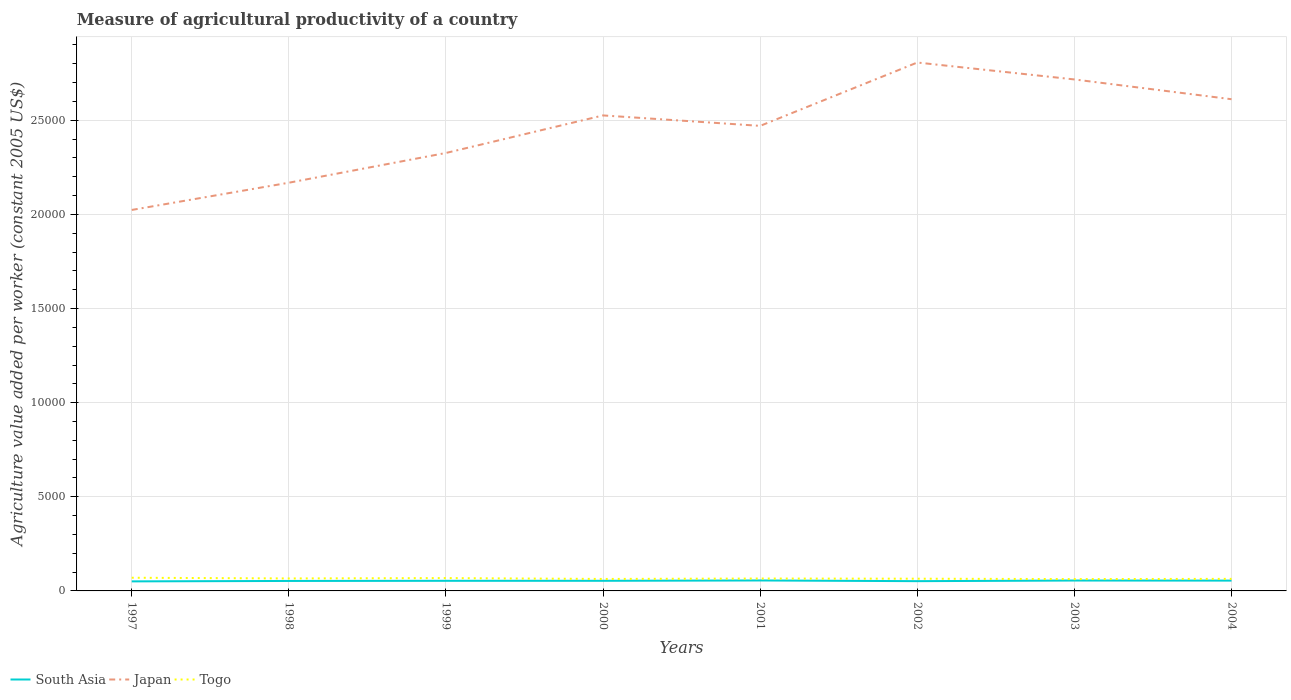Is the number of lines equal to the number of legend labels?
Provide a succinct answer. Yes. Across all years, what is the maximum measure of agricultural productivity in Japan?
Your response must be concise. 2.02e+04. What is the total measure of agricultural productivity in South Asia in the graph?
Give a very brief answer. -11.91. What is the difference between the highest and the second highest measure of agricultural productivity in Japan?
Your response must be concise. 7830.93. What is the difference between the highest and the lowest measure of agricultural productivity in Togo?
Keep it short and to the point. 4. How many lines are there?
Provide a succinct answer. 3. How many years are there in the graph?
Keep it short and to the point. 8. Does the graph contain any zero values?
Provide a short and direct response. No. Does the graph contain grids?
Your response must be concise. Yes. Where does the legend appear in the graph?
Provide a succinct answer. Bottom left. How many legend labels are there?
Your answer should be compact. 3. How are the legend labels stacked?
Ensure brevity in your answer.  Horizontal. What is the title of the graph?
Offer a terse response. Measure of agricultural productivity of a country. Does "Fragile and conflict affected situations" appear as one of the legend labels in the graph?
Your answer should be very brief. No. What is the label or title of the Y-axis?
Offer a terse response. Agriculture value added per worker (constant 2005 US$). What is the Agriculture value added per worker (constant 2005 US$) of South Asia in 1997?
Ensure brevity in your answer.  506.93. What is the Agriculture value added per worker (constant 2005 US$) of Japan in 1997?
Offer a very short reply. 2.02e+04. What is the Agriculture value added per worker (constant 2005 US$) of Togo in 1997?
Your response must be concise. 700.08. What is the Agriculture value added per worker (constant 2005 US$) in South Asia in 1998?
Keep it short and to the point. 529.46. What is the Agriculture value added per worker (constant 2005 US$) of Japan in 1998?
Your response must be concise. 2.17e+04. What is the Agriculture value added per worker (constant 2005 US$) in Togo in 1998?
Ensure brevity in your answer.  663.32. What is the Agriculture value added per worker (constant 2005 US$) in South Asia in 1999?
Provide a succinct answer. 537.23. What is the Agriculture value added per worker (constant 2005 US$) in Japan in 1999?
Make the answer very short. 2.33e+04. What is the Agriculture value added per worker (constant 2005 US$) of Togo in 1999?
Ensure brevity in your answer.  682.25. What is the Agriculture value added per worker (constant 2005 US$) in South Asia in 2000?
Give a very brief answer. 537.68. What is the Agriculture value added per worker (constant 2005 US$) in Japan in 2000?
Provide a succinct answer. 2.53e+04. What is the Agriculture value added per worker (constant 2005 US$) in Togo in 2000?
Your answer should be compact. 635.84. What is the Agriculture value added per worker (constant 2005 US$) of South Asia in 2001?
Your answer should be compact. 555.33. What is the Agriculture value added per worker (constant 2005 US$) in Japan in 2001?
Provide a succinct answer. 2.47e+04. What is the Agriculture value added per worker (constant 2005 US$) of Togo in 2001?
Provide a succinct answer. 658.87. What is the Agriculture value added per worker (constant 2005 US$) in South Asia in 2002?
Provide a succinct answer. 518.84. What is the Agriculture value added per worker (constant 2005 US$) of Japan in 2002?
Make the answer very short. 2.81e+04. What is the Agriculture value added per worker (constant 2005 US$) of Togo in 2002?
Keep it short and to the point. 649.45. What is the Agriculture value added per worker (constant 2005 US$) in South Asia in 2003?
Make the answer very short. 551.86. What is the Agriculture value added per worker (constant 2005 US$) of Japan in 2003?
Offer a terse response. 2.72e+04. What is the Agriculture value added per worker (constant 2005 US$) in Togo in 2003?
Your response must be concise. 628.99. What is the Agriculture value added per worker (constant 2005 US$) of South Asia in 2004?
Your answer should be very brief. 547.74. What is the Agriculture value added per worker (constant 2005 US$) in Japan in 2004?
Provide a succinct answer. 2.61e+04. What is the Agriculture value added per worker (constant 2005 US$) of Togo in 2004?
Provide a succinct answer. 640.82. Across all years, what is the maximum Agriculture value added per worker (constant 2005 US$) in South Asia?
Your response must be concise. 555.33. Across all years, what is the maximum Agriculture value added per worker (constant 2005 US$) in Japan?
Provide a short and direct response. 2.81e+04. Across all years, what is the maximum Agriculture value added per worker (constant 2005 US$) of Togo?
Make the answer very short. 700.08. Across all years, what is the minimum Agriculture value added per worker (constant 2005 US$) in South Asia?
Provide a short and direct response. 506.93. Across all years, what is the minimum Agriculture value added per worker (constant 2005 US$) in Japan?
Offer a terse response. 2.02e+04. Across all years, what is the minimum Agriculture value added per worker (constant 2005 US$) of Togo?
Make the answer very short. 628.99. What is the total Agriculture value added per worker (constant 2005 US$) in South Asia in the graph?
Give a very brief answer. 4285.06. What is the total Agriculture value added per worker (constant 2005 US$) of Japan in the graph?
Your answer should be compact. 1.96e+05. What is the total Agriculture value added per worker (constant 2005 US$) of Togo in the graph?
Give a very brief answer. 5259.62. What is the difference between the Agriculture value added per worker (constant 2005 US$) in South Asia in 1997 and that in 1998?
Make the answer very short. -22.53. What is the difference between the Agriculture value added per worker (constant 2005 US$) of Japan in 1997 and that in 1998?
Provide a succinct answer. -1446.39. What is the difference between the Agriculture value added per worker (constant 2005 US$) in Togo in 1997 and that in 1998?
Provide a succinct answer. 36.75. What is the difference between the Agriculture value added per worker (constant 2005 US$) in South Asia in 1997 and that in 1999?
Offer a terse response. -30.3. What is the difference between the Agriculture value added per worker (constant 2005 US$) of Japan in 1997 and that in 1999?
Keep it short and to the point. -3026.53. What is the difference between the Agriculture value added per worker (constant 2005 US$) of Togo in 1997 and that in 1999?
Give a very brief answer. 17.83. What is the difference between the Agriculture value added per worker (constant 2005 US$) of South Asia in 1997 and that in 2000?
Make the answer very short. -30.76. What is the difference between the Agriculture value added per worker (constant 2005 US$) of Japan in 1997 and that in 2000?
Offer a terse response. -5021.11. What is the difference between the Agriculture value added per worker (constant 2005 US$) of Togo in 1997 and that in 2000?
Offer a terse response. 64.24. What is the difference between the Agriculture value added per worker (constant 2005 US$) of South Asia in 1997 and that in 2001?
Your answer should be compact. -48.41. What is the difference between the Agriculture value added per worker (constant 2005 US$) in Japan in 1997 and that in 2001?
Your answer should be very brief. -4465.92. What is the difference between the Agriculture value added per worker (constant 2005 US$) of Togo in 1997 and that in 2001?
Provide a short and direct response. 41.2. What is the difference between the Agriculture value added per worker (constant 2005 US$) in South Asia in 1997 and that in 2002?
Offer a terse response. -11.91. What is the difference between the Agriculture value added per worker (constant 2005 US$) of Japan in 1997 and that in 2002?
Ensure brevity in your answer.  -7830.93. What is the difference between the Agriculture value added per worker (constant 2005 US$) of Togo in 1997 and that in 2002?
Provide a short and direct response. 50.63. What is the difference between the Agriculture value added per worker (constant 2005 US$) in South Asia in 1997 and that in 2003?
Your answer should be compact. -44.93. What is the difference between the Agriculture value added per worker (constant 2005 US$) of Japan in 1997 and that in 2003?
Offer a terse response. -6932. What is the difference between the Agriculture value added per worker (constant 2005 US$) of Togo in 1997 and that in 2003?
Your answer should be very brief. 71.09. What is the difference between the Agriculture value added per worker (constant 2005 US$) of South Asia in 1997 and that in 2004?
Provide a short and direct response. -40.81. What is the difference between the Agriculture value added per worker (constant 2005 US$) in Japan in 1997 and that in 2004?
Your answer should be compact. -5880.94. What is the difference between the Agriculture value added per worker (constant 2005 US$) of Togo in 1997 and that in 2004?
Offer a terse response. 59.26. What is the difference between the Agriculture value added per worker (constant 2005 US$) in South Asia in 1998 and that in 1999?
Your answer should be very brief. -7.77. What is the difference between the Agriculture value added per worker (constant 2005 US$) of Japan in 1998 and that in 1999?
Make the answer very short. -1580.14. What is the difference between the Agriculture value added per worker (constant 2005 US$) in Togo in 1998 and that in 1999?
Offer a very short reply. -18.92. What is the difference between the Agriculture value added per worker (constant 2005 US$) of South Asia in 1998 and that in 2000?
Ensure brevity in your answer.  -8.23. What is the difference between the Agriculture value added per worker (constant 2005 US$) of Japan in 1998 and that in 2000?
Provide a short and direct response. -3574.72. What is the difference between the Agriculture value added per worker (constant 2005 US$) in Togo in 1998 and that in 2000?
Your response must be concise. 27.49. What is the difference between the Agriculture value added per worker (constant 2005 US$) of South Asia in 1998 and that in 2001?
Ensure brevity in your answer.  -25.88. What is the difference between the Agriculture value added per worker (constant 2005 US$) in Japan in 1998 and that in 2001?
Your response must be concise. -3019.53. What is the difference between the Agriculture value added per worker (constant 2005 US$) of Togo in 1998 and that in 2001?
Keep it short and to the point. 4.45. What is the difference between the Agriculture value added per worker (constant 2005 US$) of South Asia in 1998 and that in 2002?
Your answer should be very brief. 10.62. What is the difference between the Agriculture value added per worker (constant 2005 US$) of Japan in 1998 and that in 2002?
Ensure brevity in your answer.  -6384.54. What is the difference between the Agriculture value added per worker (constant 2005 US$) of Togo in 1998 and that in 2002?
Make the answer very short. 13.88. What is the difference between the Agriculture value added per worker (constant 2005 US$) of South Asia in 1998 and that in 2003?
Your response must be concise. -22.4. What is the difference between the Agriculture value added per worker (constant 2005 US$) in Japan in 1998 and that in 2003?
Your answer should be very brief. -5485.61. What is the difference between the Agriculture value added per worker (constant 2005 US$) of Togo in 1998 and that in 2003?
Keep it short and to the point. 34.34. What is the difference between the Agriculture value added per worker (constant 2005 US$) of South Asia in 1998 and that in 2004?
Provide a succinct answer. -18.28. What is the difference between the Agriculture value added per worker (constant 2005 US$) in Japan in 1998 and that in 2004?
Your answer should be very brief. -4434.56. What is the difference between the Agriculture value added per worker (constant 2005 US$) of Togo in 1998 and that in 2004?
Ensure brevity in your answer.  22.5. What is the difference between the Agriculture value added per worker (constant 2005 US$) in South Asia in 1999 and that in 2000?
Provide a short and direct response. -0.46. What is the difference between the Agriculture value added per worker (constant 2005 US$) in Japan in 1999 and that in 2000?
Your answer should be compact. -1994.58. What is the difference between the Agriculture value added per worker (constant 2005 US$) in Togo in 1999 and that in 2000?
Ensure brevity in your answer.  46.41. What is the difference between the Agriculture value added per worker (constant 2005 US$) in South Asia in 1999 and that in 2001?
Offer a terse response. -18.11. What is the difference between the Agriculture value added per worker (constant 2005 US$) of Japan in 1999 and that in 2001?
Offer a very short reply. -1439.39. What is the difference between the Agriculture value added per worker (constant 2005 US$) in Togo in 1999 and that in 2001?
Provide a short and direct response. 23.37. What is the difference between the Agriculture value added per worker (constant 2005 US$) of South Asia in 1999 and that in 2002?
Make the answer very short. 18.39. What is the difference between the Agriculture value added per worker (constant 2005 US$) of Japan in 1999 and that in 2002?
Your answer should be compact. -4804.4. What is the difference between the Agriculture value added per worker (constant 2005 US$) of Togo in 1999 and that in 2002?
Make the answer very short. 32.8. What is the difference between the Agriculture value added per worker (constant 2005 US$) in South Asia in 1999 and that in 2003?
Make the answer very short. -14.63. What is the difference between the Agriculture value added per worker (constant 2005 US$) of Japan in 1999 and that in 2003?
Make the answer very short. -3905.46. What is the difference between the Agriculture value added per worker (constant 2005 US$) of Togo in 1999 and that in 2003?
Give a very brief answer. 53.26. What is the difference between the Agriculture value added per worker (constant 2005 US$) in South Asia in 1999 and that in 2004?
Your response must be concise. -10.51. What is the difference between the Agriculture value added per worker (constant 2005 US$) in Japan in 1999 and that in 2004?
Make the answer very short. -2854.41. What is the difference between the Agriculture value added per worker (constant 2005 US$) of Togo in 1999 and that in 2004?
Offer a terse response. 41.43. What is the difference between the Agriculture value added per worker (constant 2005 US$) of South Asia in 2000 and that in 2001?
Make the answer very short. -17.65. What is the difference between the Agriculture value added per worker (constant 2005 US$) of Japan in 2000 and that in 2001?
Give a very brief answer. 555.19. What is the difference between the Agriculture value added per worker (constant 2005 US$) of Togo in 2000 and that in 2001?
Offer a very short reply. -23.04. What is the difference between the Agriculture value added per worker (constant 2005 US$) of South Asia in 2000 and that in 2002?
Your answer should be compact. 18.85. What is the difference between the Agriculture value added per worker (constant 2005 US$) in Japan in 2000 and that in 2002?
Give a very brief answer. -2809.82. What is the difference between the Agriculture value added per worker (constant 2005 US$) of Togo in 2000 and that in 2002?
Make the answer very short. -13.61. What is the difference between the Agriculture value added per worker (constant 2005 US$) of South Asia in 2000 and that in 2003?
Make the answer very short. -14.18. What is the difference between the Agriculture value added per worker (constant 2005 US$) in Japan in 2000 and that in 2003?
Keep it short and to the point. -1910.89. What is the difference between the Agriculture value added per worker (constant 2005 US$) in Togo in 2000 and that in 2003?
Make the answer very short. 6.85. What is the difference between the Agriculture value added per worker (constant 2005 US$) of South Asia in 2000 and that in 2004?
Your answer should be very brief. -10.05. What is the difference between the Agriculture value added per worker (constant 2005 US$) of Japan in 2000 and that in 2004?
Keep it short and to the point. -859.84. What is the difference between the Agriculture value added per worker (constant 2005 US$) in Togo in 2000 and that in 2004?
Give a very brief answer. -4.98. What is the difference between the Agriculture value added per worker (constant 2005 US$) in South Asia in 2001 and that in 2002?
Keep it short and to the point. 36.5. What is the difference between the Agriculture value added per worker (constant 2005 US$) in Japan in 2001 and that in 2002?
Provide a short and direct response. -3365.01. What is the difference between the Agriculture value added per worker (constant 2005 US$) of Togo in 2001 and that in 2002?
Your answer should be very brief. 9.43. What is the difference between the Agriculture value added per worker (constant 2005 US$) of South Asia in 2001 and that in 2003?
Provide a short and direct response. 3.47. What is the difference between the Agriculture value added per worker (constant 2005 US$) of Japan in 2001 and that in 2003?
Offer a very short reply. -2466.08. What is the difference between the Agriculture value added per worker (constant 2005 US$) in Togo in 2001 and that in 2003?
Give a very brief answer. 29.88. What is the difference between the Agriculture value added per worker (constant 2005 US$) of South Asia in 2001 and that in 2004?
Your response must be concise. 7.6. What is the difference between the Agriculture value added per worker (constant 2005 US$) of Japan in 2001 and that in 2004?
Provide a succinct answer. -1415.02. What is the difference between the Agriculture value added per worker (constant 2005 US$) of Togo in 2001 and that in 2004?
Offer a very short reply. 18.05. What is the difference between the Agriculture value added per worker (constant 2005 US$) in South Asia in 2002 and that in 2003?
Your answer should be compact. -33.02. What is the difference between the Agriculture value added per worker (constant 2005 US$) of Japan in 2002 and that in 2003?
Your response must be concise. 898.93. What is the difference between the Agriculture value added per worker (constant 2005 US$) in Togo in 2002 and that in 2003?
Offer a very short reply. 20.46. What is the difference between the Agriculture value added per worker (constant 2005 US$) in South Asia in 2002 and that in 2004?
Provide a short and direct response. -28.9. What is the difference between the Agriculture value added per worker (constant 2005 US$) in Japan in 2002 and that in 2004?
Offer a very short reply. 1949.99. What is the difference between the Agriculture value added per worker (constant 2005 US$) of Togo in 2002 and that in 2004?
Your response must be concise. 8.63. What is the difference between the Agriculture value added per worker (constant 2005 US$) of South Asia in 2003 and that in 2004?
Your answer should be compact. 4.12. What is the difference between the Agriculture value added per worker (constant 2005 US$) of Japan in 2003 and that in 2004?
Give a very brief answer. 1051.05. What is the difference between the Agriculture value added per worker (constant 2005 US$) of Togo in 2003 and that in 2004?
Your answer should be compact. -11.83. What is the difference between the Agriculture value added per worker (constant 2005 US$) of South Asia in 1997 and the Agriculture value added per worker (constant 2005 US$) of Japan in 1998?
Your answer should be compact. -2.12e+04. What is the difference between the Agriculture value added per worker (constant 2005 US$) of South Asia in 1997 and the Agriculture value added per worker (constant 2005 US$) of Togo in 1998?
Ensure brevity in your answer.  -156.4. What is the difference between the Agriculture value added per worker (constant 2005 US$) of Japan in 1997 and the Agriculture value added per worker (constant 2005 US$) of Togo in 1998?
Provide a short and direct response. 1.96e+04. What is the difference between the Agriculture value added per worker (constant 2005 US$) in South Asia in 1997 and the Agriculture value added per worker (constant 2005 US$) in Japan in 1999?
Your response must be concise. -2.28e+04. What is the difference between the Agriculture value added per worker (constant 2005 US$) in South Asia in 1997 and the Agriculture value added per worker (constant 2005 US$) in Togo in 1999?
Your response must be concise. -175.32. What is the difference between the Agriculture value added per worker (constant 2005 US$) in Japan in 1997 and the Agriculture value added per worker (constant 2005 US$) in Togo in 1999?
Make the answer very short. 1.96e+04. What is the difference between the Agriculture value added per worker (constant 2005 US$) in South Asia in 1997 and the Agriculture value added per worker (constant 2005 US$) in Japan in 2000?
Your answer should be compact. -2.48e+04. What is the difference between the Agriculture value added per worker (constant 2005 US$) in South Asia in 1997 and the Agriculture value added per worker (constant 2005 US$) in Togo in 2000?
Offer a terse response. -128.91. What is the difference between the Agriculture value added per worker (constant 2005 US$) of Japan in 1997 and the Agriculture value added per worker (constant 2005 US$) of Togo in 2000?
Make the answer very short. 1.96e+04. What is the difference between the Agriculture value added per worker (constant 2005 US$) of South Asia in 1997 and the Agriculture value added per worker (constant 2005 US$) of Japan in 2001?
Provide a short and direct response. -2.42e+04. What is the difference between the Agriculture value added per worker (constant 2005 US$) of South Asia in 1997 and the Agriculture value added per worker (constant 2005 US$) of Togo in 2001?
Give a very brief answer. -151.95. What is the difference between the Agriculture value added per worker (constant 2005 US$) in Japan in 1997 and the Agriculture value added per worker (constant 2005 US$) in Togo in 2001?
Your response must be concise. 1.96e+04. What is the difference between the Agriculture value added per worker (constant 2005 US$) of South Asia in 1997 and the Agriculture value added per worker (constant 2005 US$) of Japan in 2002?
Your response must be concise. -2.76e+04. What is the difference between the Agriculture value added per worker (constant 2005 US$) of South Asia in 1997 and the Agriculture value added per worker (constant 2005 US$) of Togo in 2002?
Your answer should be compact. -142.52. What is the difference between the Agriculture value added per worker (constant 2005 US$) in Japan in 1997 and the Agriculture value added per worker (constant 2005 US$) in Togo in 2002?
Offer a terse response. 1.96e+04. What is the difference between the Agriculture value added per worker (constant 2005 US$) in South Asia in 1997 and the Agriculture value added per worker (constant 2005 US$) in Japan in 2003?
Give a very brief answer. -2.67e+04. What is the difference between the Agriculture value added per worker (constant 2005 US$) in South Asia in 1997 and the Agriculture value added per worker (constant 2005 US$) in Togo in 2003?
Your answer should be very brief. -122.06. What is the difference between the Agriculture value added per worker (constant 2005 US$) in Japan in 1997 and the Agriculture value added per worker (constant 2005 US$) in Togo in 2003?
Make the answer very short. 1.96e+04. What is the difference between the Agriculture value added per worker (constant 2005 US$) in South Asia in 1997 and the Agriculture value added per worker (constant 2005 US$) in Japan in 2004?
Keep it short and to the point. -2.56e+04. What is the difference between the Agriculture value added per worker (constant 2005 US$) of South Asia in 1997 and the Agriculture value added per worker (constant 2005 US$) of Togo in 2004?
Give a very brief answer. -133.89. What is the difference between the Agriculture value added per worker (constant 2005 US$) of Japan in 1997 and the Agriculture value added per worker (constant 2005 US$) of Togo in 2004?
Offer a very short reply. 1.96e+04. What is the difference between the Agriculture value added per worker (constant 2005 US$) in South Asia in 1998 and the Agriculture value added per worker (constant 2005 US$) in Japan in 1999?
Keep it short and to the point. -2.27e+04. What is the difference between the Agriculture value added per worker (constant 2005 US$) of South Asia in 1998 and the Agriculture value added per worker (constant 2005 US$) of Togo in 1999?
Your answer should be compact. -152.79. What is the difference between the Agriculture value added per worker (constant 2005 US$) in Japan in 1998 and the Agriculture value added per worker (constant 2005 US$) in Togo in 1999?
Your answer should be compact. 2.10e+04. What is the difference between the Agriculture value added per worker (constant 2005 US$) of South Asia in 1998 and the Agriculture value added per worker (constant 2005 US$) of Japan in 2000?
Your response must be concise. -2.47e+04. What is the difference between the Agriculture value added per worker (constant 2005 US$) in South Asia in 1998 and the Agriculture value added per worker (constant 2005 US$) in Togo in 2000?
Your answer should be compact. -106.38. What is the difference between the Agriculture value added per worker (constant 2005 US$) of Japan in 1998 and the Agriculture value added per worker (constant 2005 US$) of Togo in 2000?
Give a very brief answer. 2.10e+04. What is the difference between the Agriculture value added per worker (constant 2005 US$) in South Asia in 1998 and the Agriculture value added per worker (constant 2005 US$) in Japan in 2001?
Your answer should be compact. -2.42e+04. What is the difference between the Agriculture value added per worker (constant 2005 US$) in South Asia in 1998 and the Agriculture value added per worker (constant 2005 US$) in Togo in 2001?
Offer a very short reply. -129.42. What is the difference between the Agriculture value added per worker (constant 2005 US$) in Japan in 1998 and the Agriculture value added per worker (constant 2005 US$) in Togo in 2001?
Offer a very short reply. 2.10e+04. What is the difference between the Agriculture value added per worker (constant 2005 US$) in South Asia in 1998 and the Agriculture value added per worker (constant 2005 US$) in Japan in 2002?
Your answer should be compact. -2.75e+04. What is the difference between the Agriculture value added per worker (constant 2005 US$) of South Asia in 1998 and the Agriculture value added per worker (constant 2005 US$) of Togo in 2002?
Provide a short and direct response. -119.99. What is the difference between the Agriculture value added per worker (constant 2005 US$) in Japan in 1998 and the Agriculture value added per worker (constant 2005 US$) in Togo in 2002?
Ensure brevity in your answer.  2.10e+04. What is the difference between the Agriculture value added per worker (constant 2005 US$) of South Asia in 1998 and the Agriculture value added per worker (constant 2005 US$) of Japan in 2003?
Your response must be concise. -2.66e+04. What is the difference between the Agriculture value added per worker (constant 2005 US$) in South Asia in 1998 and the Agriculture value added per worker (constant 2005 US$) in Togo in 2003?
Give a very brief answer. -99.53. What is the difference between the Agriculture value added per worker (constant 2005 US$) of Japan in 1998 and the Agriculture value added per worker (constant 2005 US$) of Togo in 2003?
Your answer should be compact. 2.11e+04. What is the difference between the Agriculture value added per worker (constant 2005 US$) of South Asia in 1998 and the Agriculture value added per worker (constant 2005 US$) of Japan in 2004?
Offer a very short reply. -2.56e+04. What is the difference between the Agriculture value added per worker (constant 2005 US$) in South Asia in 1998 and the Agriculture value added per worker (constant 2005 US$) in Togo in 2004?
Offer a terse response. -111.36. What is the difference between the Agriculture value added per worker (constant 2005 US$) of Japan in 1998 and the Agriculture value added per worker (constant 2005 US$) of Togo in 2004?
Your answer should be compact. 2.10e+04. What is the difference between the Agriculture value added per worker (constant 2005 US$) in South Asia in 1999 and the Agriculture value added per worker (constant 2005 US$) in Japan in 2000?
Provide a succinct answer. -2.47e+04. What is the difference between the Agriculture value added per worker (constant 2005 US$) in South Asia in 1999 and the Agriculture value added per worker (constant 2005 US$) in Togo in 2000?
Offer a terse response. -98.61. What is the difference between the Agriculture value added per worker (constant 2005 US$) in Japan in 1999 and the Agriculture value added per worker (constant 2005 US$) in Togo in 2000?
Offer a very short reply. 2.26e+04. What is the difference between the Agriculture value added per worker (constant 2005 US$) of South Asia in 1999 and the Agriculture value added per worker (constant 2005 US$) of Japan in 2001?
Keep it short and to the point. -2.42e+04. What is the difference between the Agriculture value added per worker (constant 2005 US$) in South Asia in 1999 and the Agriculture value added per worker (constant 2005 US$) in Togo in 2001?
Make the answer very short. -121.65. What is the difference between the Agriculture value added per worker (constant 2005 US$) of Japan in 1999 and the Agriculture value added per worker (constant 2005 US$) of Togo in 2001?
Provide a short and direct response. 2.26e+04. What is the difference between the Agriculture value added per worker (constant 2005 US$) in South Asia in 1999 and the Agriculture value added per worker (constant 2005 US$) in Japan in 2002?
Your answer should be compact. -2.75e+04. What is the difference between the Agriculture value added per worker (constant 2005 US$) in South Asia in 1999 and the Agriculture value added per worker (constant 2005 US$) in Togo in 2002?
Your answer should be compact. -112.22. What is the difference between the Agriculture value added per worker (constant 2005 US$) of Japan in 1999 and the Agriculture value added per worker (constant 2005 US$) of Togo in 2002?
Offer a terse response. 2.26e+04. What is the difference between the Agriculture value added per worker (constant 2005 US$) of South Asia in 1999 and the Agriculture value added per worker (constant 2005 US$) of Japan in 2003?
Offer a very short reply. -2.66e+04. What is the difference between the Agriculture value added per worker (constant 2005 US$) of South Asia in 1999 and the Agriculture value added per worker (constant 2005 US$) of Togo in 2003?
Ensure brevity in your answer.  -91.76. What is the difference between the Agriculture value added per worker (constant 2005 US$) in Japan in 1999 and the Agriculture value added per worker (constant 2005 US$) in Togo in 2003?
Provide a succinct answer. 2.26e+04. What is the difference between the Agriculture value added per worker (constant 2005 US$) in South Asia in 1999 and the Agriculture value added per worker (constant 2005 US$) in Japan in 2004?
Provide a short and direct response. -2.56e+04. What is the difference between the Agriculture value added per worker (constant 2005 US$) in South Asia in 1999 and the Agriculture value added per worker (constant 2005 US$) in Togo in 2004?
Your answer should be very brief. -103.59. What is the difference between the Agriculture value added per worker (constant 2005 US$) of Japan in 1999 and the Agriculture value added per worker (constant 2005 US$) of Togo in 2004?
Give a very brief answer. 2.26e+04. What is the difference between the Agriculture value added per worker (constant 2005 US$) in South Asia in 2000 and the Agriculture value added per worker (constant 2005 US$) in Japan in 2001?
Offer a very short reply. -2.42e+04. What is the difference between the Agriculture value added per worker (constant 2005 US$) of South Asia in 2000 and the Agriculture value added per worker (constant 2005 US$) of Togo in 2001?
Keep it short and to the point. -121.19. What is the difference between the Agriculture value added per worker (constant 2005 US$) of Japan in 2000 and the Agriculture value added per worker (constant 2005 US$) of Togo in 2001?
Ensure brevity in your answer.  2.46e+04. What is the difference between the Agriculture value added per worker (constant 2005 US$) in South Asia in 2000 and the Agriculture value added per worker (constant 2005 US$) in Japan in 2002?
Offer a terse response. -2.75e+04. What is the difference between the Agriculture value added per worker (constant 2005 US$) of South Asia in 2000 and the Agriculture value added per worker (constant 2005 US$) of Togo in 2002?
Offer a terse response. -111.76. What is the difference between the Agriculture value added per worker (constant 2005 US$) in Japan in 2000 and the Agriculture value added per worker (constant 2005 US$) in Togo in 2002?
Keep it short and to the point. 2.46e+04. What is the difference between the Agriculture value added per worker (constant 2005 US$) in South Asia in 2000 and the Agriculture value added per worker (constant 2005 US$) in Japan in 2003?
Ensure brevity in your answer.  -2.66e+04. What is the difference between the Agriculture value added per worker (constant 2005 US$) of South Asia in 2000 and the Agriculture value added per worker (constant 2005 US$) of Togo in 2003?
Your response must be concise. -91.31. What is the difference between the Agriculture value added per worker (constant 2005 US$) in Japan in 2000 and the Agriculture value added per worker (constant 2005 US$) in Togo in 2003?
Keep it short and to the point. 2.46e+04. What is the difference between the Agriculture value added per worker (constant 2005 US$) in South Asia in 2000 and the Agriculture value added per worker (constant 2005 US$) in Japan in 2004?
Offer a terse response. -2.56e+04. What is the difference between the Agriculture value added per worker (constant 2005 US$) of South Asia in 2000 and the Agriculture value added per worker (constant 2005 US$) of Togo in 2004?
Provide a succinct answer. -103.14. What is the difference between the Agriculture value added per worker (constant 2005 US$) of Japan in 2000 and the Agriculture value added per worker (constant 2005 US$) of Togo in 2004?
Keep it short and to the point. 2.46e+04. What is the difference between the Agriculture value added per worker (constant 2005 US$) in South Asia in 2001 and the Agriculture value added per worker (constant 2005 US$) in Japan in 2002?
Provide a short and direct response. -2.75e+04. What is the difference between the Agriculture value added per worker (constant 2005 US$) in South Asia in 2001 and the Agriculture value added per worker (constant 2005 US$) in Togo in 2002?
Provide a short and direct response. -94.11. What is the difference between the Agriculture value added per worker (constant 2005 US$) of Japan in 2001 and the Agriculture value added per worker (constant 2005 US$) of Togo in 2002?
Ensure brevity in your answer.  2.41e+04. What is the difference between the Agriculture value added per worker (constant 2005 US$) of South Asia in 2001 and the Agriculture value added per worker (constant 2005 US$) of Japan in 2003?
Offer a very short reply. -2.66e+04. What is the difference between the Agriculture value added per worker (constant 2005 US$) of South Asia in 2001 and the Agriculture value added per worker (constant 2005 US$) of Togo in 2003?
Offer a very short reply. -73.66. What is the difference between the Agriculture value added per worker (constant 2005 US$) in Japan in 2001 and the Agriculture value added per worker (constant 2005 US$) in Togo in 2003?
Your answer should be very brief. 2.41e+04. What is the difference between the Agriculture value added per worker (constant 2005 US$) in South Asia in 2001 and the Agriculture value added per worker (constant 2005 US$) in Japan in 2004?
Ensure brevity in your answer.  -2.56e+04. What is the difference between the Agriculture value added per worker (constant 2005 US$) in South Asia in 2001 and the Agriculture value added per worker (constant 2005 US$) in Togo in 2004?
Your answer should be very brief. -85.49. What is the difference between the Agriculture value added per worker (constant 2005 US$) in Japan in 2001 and the Agriculture value added per worker (constant 2005 US$) in Togo in 2004?
Your response must be concise. 2.41e+04. What is the difference between the Agriculture value added per worker (constant 2005 US$) of South Asia in 2002 and the Agriculture value added per worker (constant 2005 US$) of Japan in 2003?
Give a very brief answer. -2.66e+04. What is the difference between the Agriculture value added per worker (constant 2005 US$) in South Asia in 2002 and the Agriculture value added per worker (constant 2005 US$) in Togo in 2003?
Offer a very short reply. -110.15. What is the difference between the Agriculture value added per worker (constant 2005 US$) of Japan in 2002 and the Agriculture value added per worker (constant 2005 US$) of Togo in 2003?
Make the answer very short. 2.74e+04. What is the difference between the Agriculture value added per worker (constant 2005 US$) of South Asia in 2002 and the Agriculture value added per worker (constant 2005 US$) of Japan in 2004?
Ensure brevity in your answer.  -2.56e+04. What is the difference between the Agriculture value added per worker (constant 2005 US$) of South Asia in 2002 and the Agriculture value added per worker (constant 2005 US$) of Togo in 2004?
Offer a terse response. -121.98. What is the difference between the Agriculture value added per worker (constant 2005 US$) of Japan in 2002 and the Agriculture value added per worker (constant 2005 US$) of Togo in 2004?
Make the answer very short. 2.74e+04. What is the difference between the Agriculture value added per worker (constant 2005 US$) in South Asia in 2003 and the Agriculture value added per worker (constant 2005 US$) in Japan in 2004?
Your answer should be compact. -2.56e+04. What is the difference between the Agriculture value added per worker (constant 2005 US$) in South Asia in 2003 and the Agriculture value added per worker (constant 2005 US$) in Togo in 2004?
Give a very brief answer. -88.96. What is the difference between the Agriculture value added per worker (constant 2005 US$) of Japan in 2003 and the Agriculture value added per worker (constant 2005 US$) of Togo in 2004?
Ensure brevity in your answer.  2.65e+04. What is the average Agriculture value added per worker (constant 2005 US$) of South Asia per year?
Ensure brevity in your answer.  535.63. What is the average Agriculture value added per worker (constant 2005 US$) of Japan per year?
Your response must be concise. 2.46e+04. What is the average Agriculture value added per worker (constant 2005 US$) of Togo per year?
Give a very brief answer. 657.45. In the year 1997, what is the difference between the Agriculture value added per worker (constant 2005 US$) in South Asia and Agriculture value added per worker (constant 2005 US$) in Japan?
Offer a very short reply. -1.97e+04. In the year 1997, what is the difference between the Agriculture value added per worker (constant 2005 US$) of South Asia and Agriculture value added per worker (constant 2005 US$) of Togo?
Keep it short and to the point. -193.15. In the year 1997, what is the difference between the Agriculture value added per worker (constant 2005 US$) in Japan and Agriculture value added per worker (constant 2005 US$) in Togo?
Your answer should be very brief. 1.95e+04. In the year 1998, what is the difference between the Agriculture value added per worker (constant 2005 US$) of South Asia and Agriculture value added per worker (constant 2005 US$) of Japan?
Provide a succinct answer. -2.12e+04. In the year 1998, what is the difference between the Agriculture value added per worker (constant 2005 US$) of South Asia and Agriculture value added per worker (constant 2005 US$) of Togo?
Keep it short and to the point. -133.87. In the year 1998, what is the difference between the Agriculture value added per worker (constant 2005 US$) in Japan and Agriculture value added per worker (constant 2005 US$) in Togo?
Keep it short and to the point. 2.10e+04. In the year 1999, what is the difference between the Agriculture value added per worker (constant 2005 US$) of South Asia and Agriculture value added per worker (constant 2005 US$) of Japan?
Your answer should be compact. -2.27e+04. In the year 1999, what is the difference between the Agriculture value added per worker (constant 2005 US$) in South Asia and Agriculture value added per worker (constant 2005 US$) in Togo?
Provide a succinct answer. -145.02. In the year 1999, what is the difference between the Agriculture value added per worker (constant 2005 US$) in Japan and Agriculture value added per worker (constant 2005 US$) in Togo?
Give a very brief answer. 2.26e+04. In the year 2000, what is the difference between the Agriculture value added per worker (constant 2005 US$) in South Asia and Agriculture value added per worker (constant 2005 US$) in Japan?
Keep it short and to the point. -2.47e+04. In the year 2000, what is the difference between the Agriculture value added per worker (constant 2005 US$) in South Asia and Agriculture value added per worker (constant 2005 US$) in Togo?
Give a very brief answer. -98.15. In the year 2000, what is the difference between the Agriculture value added per worker (constant 2005 US$) of Japan and Agriculture value added per worker (constant 2005 US$) of Togo?
Ensure brevity in your answer.  2.46e+04. In the year 2001, what is the difference between the Agriculture value added per worker (constant 2005 US$) in South Asia and Agriculture value added per worker (constant 2005 US$) in Japan?
Offer a very short reply. -2.41e+04. In the year 2001, what is the difference between the Agriculture value added per worker (constant 2005 US$) of South Asia and Agriculture value added per worker (constant 2005 US$) of Togo?
Offer a terse response. -103.54. In the year 2001, what is the difference between the Agriculture value added per worker (constant 2005 US$) of Japan and Agriculture value added per worker (constant 2005 US$) of Togo?
Your answer should be very brief. 2.40e+04. In the year 2002, what is the difference between the Agriculture value added per worker (constant 2005 US$) in South Asia and Agriculture value added per worker (constant 2005 US$) in Japan?
Offer a terse response. -2.75e+04. In the year 2002, what is the difference between the Agriculture value added per worker (constant 2005 US$) of South Asia and Agriculture value added per worker (constant 2005 US$) of Togo?
Make the answer very short. -130.61. In the year 2002, what is the difference between the Agriculture value added per worker (constant 2005 US$) of Japan and Agriculture value added per worker (constant 2005 US$) of Togo?
Offer a terse response. 2.74e+04. In the year 2003, what is the difference between the Agriculture value added per worker (constant 2005 US$) of South Asia and Agriculture value added per worker (constant 2005 US$) of Japan?
Your response must be concise. -2.66e+04. In the year 2003, what is the difference between the Agriculture value added per worker (constant 2005 US$) of South Asia and Agriculture value added per worker (constant 2005 US$) of Togo?
Offer a very short reply. -77.13. In the year 2003, what is the difference between the Agriculture value added per worker (constant 2005 US$) in Japan and Agriculture value added per worker (constant 2005 US$) in Togo?
Give a very brief answer. 2.65e+04. In the year 2004, what is the difference between the Agriculture value added per worker (constant 2005 US$) in South Asia and Agriculture value added per worker (constant 2005 US$) in Japan?
Provide a succinct answer. -2.56e+04. In the year 2004, what is the difference between the Agriculture value added per worker (constant 2005 US$) of South Asia and Agriculture value added per worker (constant 2005 US$) of Togo?
Ensure brevity in your answer.  -93.08. In the year 2004, what is the difference between the Agriculture value added per worker (constant 2005 US$) of Japan and Agriculture value added per worker (constant 2005 US$) of Togo?
Offer a very short reply. 2.55e+04. What is the ratio of the Agriculture value added per worker (constant 2005 US$) of South Asia in 1997 to that in 1998?
Make the answer very short. 0.96. What is the ratio of the Agriculture value added per worker (constant 2005 US$) in Togo in 1997 to that in 1998?
Offer a very short reply. 1.06. What is the ratio of the Agriculture value added per worker (constant 2005 US$) of South Asia in 1997 to that in 1999?
Offer a terse response. 0.94. What is the ratio of the Agriculture value added per worker (constant 2005 US$) in Japan in 1997 to that in 1999?
Your answer should be very brief. 0.87. What is the ratio of the Agriculture value added per worker (constant 2005 US$) in Togo in 1997 to that in 1999?
Provide a short and direct response. 1.03. What is the ratio of the Agriculture value added per worker (constant 2005 US$) in South Asia in 1997 to that in 2000?
Ensure brevity in your answer.  0.94. What is the ratio of the Agriculture value added per worker (constant 2005 US$) of Japan in 1997 to that in 2000?
Give a very brief answer. 0.8. What is the ratio of the Agriculture value added per worker (constant 2005 US$) of Togo in 1997 to that in 2000?
Your answer should be very brief. 1.1. What is the ratio of the Agriculture value added per worker (constant 2005 US$) of South Asia in 1997 to that in 2001?
Your answer should be very brief. 0.91. What is the ratio of the Agriculture value added per worker (constant 2005 US$) in Japan in 1997 to that in 2001?
Provide a short and direct response. 0.82. What is the ratio of the Agriculture value added per worker (constant 2005 US$) in Togo in 1997 to that in 2001?
Your answer should be very brief. 1.06. What is the ratio of the Agriculture value added per worker (constant 2005 US$) of Japan in 1997 to that in 2002?
Offer a terse response. 0.72. What is the ratio of the Agriculture value added per worker (constant 2005 US$) of Togo in 1997 to that in 2002?
Your answer should be compact. 1.08. What is the ratio of the Agriculture value added per worker (constant 2005 US$) of South Asia in 1997 to that in 2003?
Your answer should be compact. 0.92. What is the ratio of the Agriculture value added per worker (constant 2005 US$) of Japan in 1997 to that in 2003?
Your response must be concise. 0.74. What is the ratio of the Agriculture value added per worker (constant 2005 US$) in Togo in 1997 to that in 2003?
Offer a very short reply. 1.11. What is the ratio of the Agriculture value added per worker (constant 2005 US$) in South Asia in 1997 to that in 2004?
Give a very brief answer. 0.93. What is the ratio of the Agriculture value added per worker (constant 2005 US$) in Japan in 1997 to that in 2004?
Your response must be concise. 0.77. What is the ratio of the Agriculture value added per worker (constant 2005 US$) in Togo in 1997 to that in 2004?
Provide a succinct answer. 1.09. What is the ratio of the Agriculture value added per worker (constant 2005 US$) of South Asia in 1998 to that in 1999?
Provide a short and direct response. 0.99. What is the ratio of the Agriculture value added per worker (constant 2005 US$) in Japan in 1998 to that in 1999?
Your answer should be compact. 0.93. What is the ratio of the Agriculture value added per worker (constant 2005 US$) in Togo in 1998 to that in 1999?
Your response must be concise. 0.97. What is the ratio of the Agriculture value added per worker (constant 2005 US$) in South Asia in 1998 to that in 2000?
Your answer should be very brief. 0.98. What is the ratio of the Agriculture value added per worker (constant 2005 US$) in Japan in 1998 to that in 2000?
Offer a very short reply. 0.86. What is the ratio of the Agriculture value added per worker (constant 2005 US$) in Togo in 1998 to that in 2000?
Your response must be concise. 1.04. What is the ratio of the Agriculture value added per worker (constant 2005 US$) in South Asia in 1998 to that in 2001?
Your response must be concise. 0.95. What is the ratio of the Agriculture value added per worker (constant 2005 US$) of Japan in 1998 to that in 2001?
Offer a terse response. 0.88. What is the ratio of the Agriculture value added per worker (constant 2005 US$) in Togo in 1998 to that in 2001?
Make the answer very short. 1.01. What is the ratio of the Agriculture value added per worker (constant 2005 US$) in South Asia in 1998 to that in 2002?
Keep it short and to the point. 1.02. What is the ratio of the Agriculture value added per worker (constant 2005 US$) of Japan in 1998 to that in 2002?
Offer a terse response. 0.77. What is the ratio of the Agriculture value added per worker (constant 2005 US$) in Togo in 1998 to that in 2002?
Make the answer very short. 1.02. What is the ratio of the Agriculture value added per worker (constant 2005 US$) of South Asia in 1998 to that in 2003?
Provide a short and direct response. 0.96. What is the ratio of the Agriculture value added per worker (constant 2005 US$) in Japan in 1998 to that in 2003?
Offer a terse response. 0.8. What is the ratio of the Agriculture value added per worker (constant 2005 US$) in Togo in 1998 to that in 2003?
Offer a terse response. 1.05. What is the ratio of the Agriculture value added per worker (constant 2005 US$) of South Asia in 1998 to that in 2004?
Your answer should be very brief. 0.97. What is the ratio of the Agriculture value added per worker (constant 2005 US$) of Japan in 1998 to that in 2004?
Your answer should be compact. 0.83. What is the ratio of the Agriculture value added per worker (constant 2005 US$) in Togo in 1998 to that in 2004?
Provide a succinct answer. 1.04. What is the ratio of the Agriculture value added per worker (constant 2005 US$) in South Asia in 1999 to that in 2000?
Provide a short and direct response. 1. What is the ratio of the Agriculture value added per worker (constant 2005 US$) in Japan in 1999 to that in 2000?
Offer a terse response. 0.92. What is the ratio of the Agriculture value added per worker (constant 2005 US$) of Togo in 1999 to that in 2000?
Your answer should be compact. 1.07. What is the ratio of the Agriculture value added per worker (constant 2005 US$) of South Asia in 1999 to that in 2001?
Your response must be concise. 0.97. What is the ratio of the Agriculture value added per worker (constant 2005 US$) of Japan in 1999 to that in 2001?
Your answer should be very brief. 0.94. What is the ratio of the Agriculture value added per worker (constant 2005 US$) in Togo in 1999 to that in 2001?
Offer a terse response. 1.04. What is the ratio of the Agriculture value added per worker (constant 2005 US$) in South Asia in 1999 to that in 2002?
Offer a very short reply. 1.04. What is the ratio of the Agriculture value added per worker (constant 2005 US$) in Japan in 1999 to that in 2002?
Give a very brief answer. 0.83. What is the ratio of the Agriculture value added per worker (constant 2005 US$) in Togo in 1999 to that in 2002?
Offer a terse response. 1.05. What is the ratio of the Agriculture value added per worker (constant 2005 US$) in South Asia in 1999 to that in 2003?
Provide a short and direct response. 0.97. What is the ratio of the Agriculture value added per worker (constant 2005 US$) in Japan in 1999 to that in 2003?
Your answer should be compact. 0.86. What is the ratio of the Agriculture value added per worker (constant 2005 US$) of Togo in 1999 to that in 2003?
Your answer should be very brief. 1.08. What is the ratio of the Agriculture value added per worker (constant 2005 US$) in South Asia in 1999 to that in 2004?
Ensure brevity in your answer.  0.98. What is the ratio of the Agriculture value added per worker (constant 2005 US$) of Japan in 1999 to that in 2004?
Your answer should be compact. 0.89. What is the ratio of the Agriculture value added per worker (constant 2005 US$) in Togo in 1999 to that in 2004?
Keep it short and to the point. 1.06. What is the ratio of the Agriculture value added per worker (constant 2005 US$) of South Asia in 2000 to that in 2001?
Provide a succinct answer. 0.97. What is the ratio of the Agriculture value added per worker (constant 2005 US$) of Japan in 2000 to that in 2001?
Offer a very short reply. 1.02. What is the ratio of the Agriculture value added per worker (constant 2005 US$) in Togo in 2000 to that in 2001?
Offer a very short reply. 0.96. What is the ratio of the Agriculture value added per worker (constant 2005 US$) in South Asia in 2000 to that in 2002?
Your response must be concise. 1.04. What is the ratio of the Agriculture value added per worker (constant 2005 US$) in Japan in 2000 to that in 2002?
Ensure brevity in your answer.  0.9. What is the ratio of the Agriculture value added per worker (constant 2005 US$) in South Asia in 2000 to that in 2003?
Your answer should be compact. 0.97. What is the ratio of the Agriculture value added per worker (constant 2005 US$) in Japan in 2000 to that in 2003?
Ensure brevity in your answer.  0.93. What is the ratio of the Agriculture value added per worker (constant 2005 US$) in Togo in 2000 to that in 2003?
Provide a succinct answer. 1.01. What is the ratio of the Agriculture value added per worker (constant 2005 US$) in South Asia in 2000 to that in 2004?
Make the answer very short. 0.98. What is the ratio of the Agriculture value added per worker (constant 2005 US$) in Japan in 2000 to that in 2004?
Provide a succinct answer. 0.97. What is the ratio of the Agriculture value added per worker (constant 2005 US$) in Togo in 2000 to that in 2004?
Offer a very short reply. 0.99. What is the ratio of the Agriculture value added per worker (constant 2005 US$) in South Asia in 2001 to that in 2002?
Provide a short and direct response. 1.07. What is the ratio of the Agriculture value added per worker (constant 2005 US$) in Japan in 2001 to that in 2002?
Your answer should be very brief. 0.88. What is the ratio of the Agriculture value added per worker (constant 2005 US$) of Togo in 2001 to that in 2002?
Keep it short and to the point. 1.01. What is the ratio of the Agriculture value added per worker (constant 2005 US$) in Japan in 2001 to that in 2003?
Give a very brief answer. 0.91. What is the ratio of the Agriculture value added per worker (constant 2005 US$) in Togo in 2001 to that in 2003?
Provide a short and direct response. 1.05. What is the ratio of the Agriculture value added per worker (constant 2005 US$) in South Asia in 2001 to that in 2004?
Your answer should be very brief. 1.01. What is the ratio of the Agriculture value added per worker (constant 2005 US$) of Japan in 2001 to that in 2004?
Ensure brevity in your answer.  0.95. What is the ratio of the Agriculture value added per worker (constant 2005 US$) in Togo in 2001 to that in 2004?
Your response must be concise. 1.03. What is the ratio of the Agriculture value added per worker (constant 2005 US$) in South Asia in 2002 to that in 2003?
Provide a succinct answer. 0.94. What is the ratio of the Agriculture value added per worker (constant 2005 US$) of Japan in 2002 to that in 2003?
Offer a terse response. 1.03. What is the ratio of the Agriculture value added per worker (constant 2005 US$) of Togo in 2002 to that in 2003?
Offer a terse response. 1.03. What is the ratio of the Agriculture value added per worker (constant 2005 US$) of South Asia in 2002 to that in 2004?
Your answer should be compact. 0.95. What is the ratio of the Agriculture value added per worker (constant 2005 US$) in Japan in 2002 to that in 2004?
Offer a very short reply. 1.07. What is the ratio of the Agriculture value added per worker (constant 2005 US$) of Togo in 2002 to that in 2004?
Make the answer very short. 1.01. What is the ratio of the Agriculture value added per worker (constant 2005 US$) of South Asia in 2003 to that in 2004?
Give a very brief answer. 1.01. What is the ratio of the Agriculture value added per worker (constant 2005 US$) in Japan in 2003 to that in 2004?
Keep it short and to the point. 1.04. What is the ratio of the Agriculture value added per worker (constant 2005 US$) in Togo in 2003 to that in 2004?
Offer a terse response. 0.98. What is the difference between the highest and the second highest Agriculture value added per worker (constant 2005 US$) in South Asia?
Your response must be concise. 3.47. What is the difference between the highest and the second highest Agriculture value added per worker (constant 2005 US$) of Japan?
Provide a short and direct response. 898.93. What is the difference between the highest and the second highest Agriculture value added per worker (constant 2005 US$) in Togo?
Make the answer very short. 17.83. What is the difference between the highest and the lowest Agriculture value added per worker (constant 2005 US$) in South Asia?
Provide a short and direct response. 48.41. What is the difference between the highest and the lowest Agriculture value added per worker (constant 2005 US$) of Japan?
Your response must be concise. 7830.93. What is the difference between the highest and the lowest Agriculture value added per worker (constant 2005 US$) in Togo?
Make the answer very short. 71.09. 